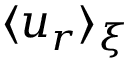Convert formula to latex. <formula><loc_0><loc_0><loc_500><loc_500>\langle u _ { r } \rangle _ { \xi }</formula> 